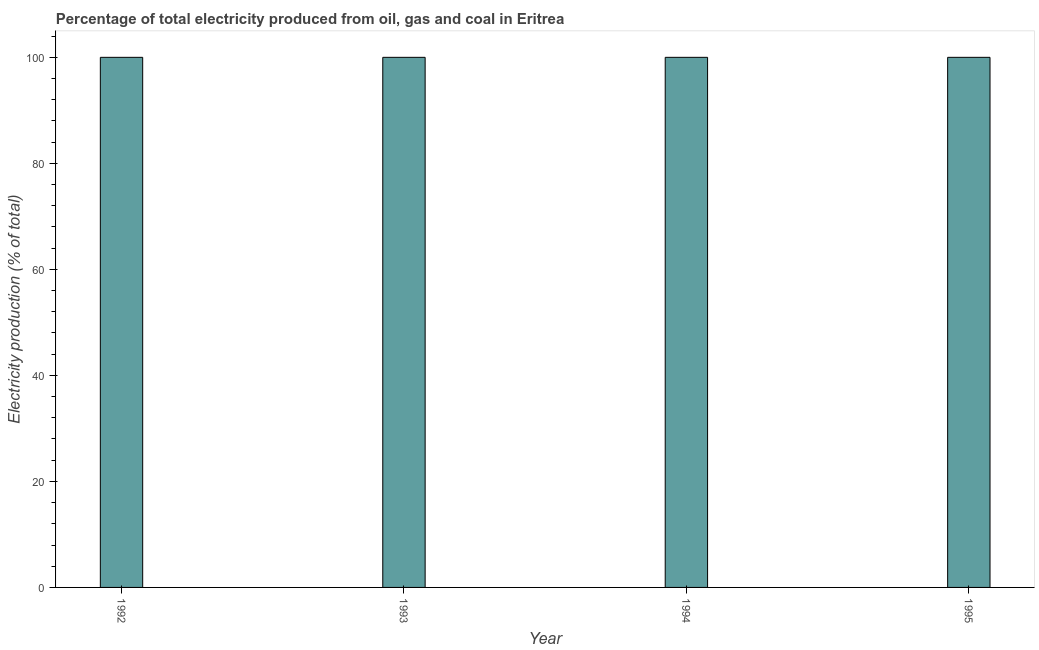What is the title of the graph?
Your response must be concise. Percentage of total electricity produced from oil, gas and coal in Eritrea. What is the label or title of the Y-axis?
Offer a very short reply. Electricity production (% of total). In which year was the electricity production minimum?
Give a very brief answer. 1992. What is the median electricity production?
Offer a terse response. 100. In how many years, is the electricity production greater than 64 %?
Provide a short and direct response. 4. Do a majority of the years between 1992 and 1994 (inclusive) have electricity production greater than 24 %?
Ensure brevity in your answer.  Yes. What is the difference between the highest and the second highest electricity production?
Offer a very short reply. 0. Is the sum of the electricity production in 1994 and 1995 greater than the maximum electricity production across all years?
Your answer should be compact. Yes. In how many years, is the electricity production greater than the average electricity production taken over all years?
Offer a terse response. 0. Are all the bars in the graph horizontal?
Make the answer very short. No. How many years are there in the graph?
Your response must be concise. 4. Are the values on the major ticks of Y-axis written in scientific E-notation?
Make the answer very short. No. What is the Electricity production (% of total) of 1994?
Offer a very short reply. 100. What is the difference between the Electricity production (% of total) in 1992 and 1993?
Offer a terse response. 0. What is the difference between the Electricity production (% of total) in 1992 and 1994?
Your response must be concise. 0. What is the difference between the Electricity production (% of total) in 1993 and 1994?
Provide a short and direct response. 0. What is the difference between the Electricity production (% of total) in 1993 and 1995?
Offer a very short reply. 0. What is the ratio of the Electricity production (% of total) in 1992 to that in 1994?
Your answer should be compact. 1. What is the ratio of the Electricity production (% of total) in 1993 to that in 1994?
Make the answer very short. 1. 